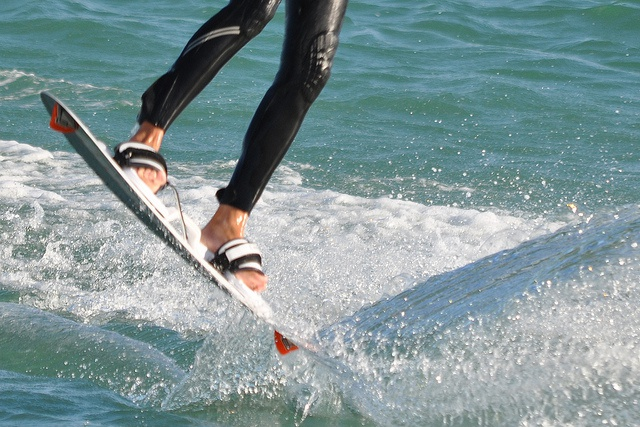Describe the objects in this image and their specific colors. I can see people in teal, black, gray, brown, and white tones and surfboard in teal, white, gray, darkgray, and purple tones in this image. 